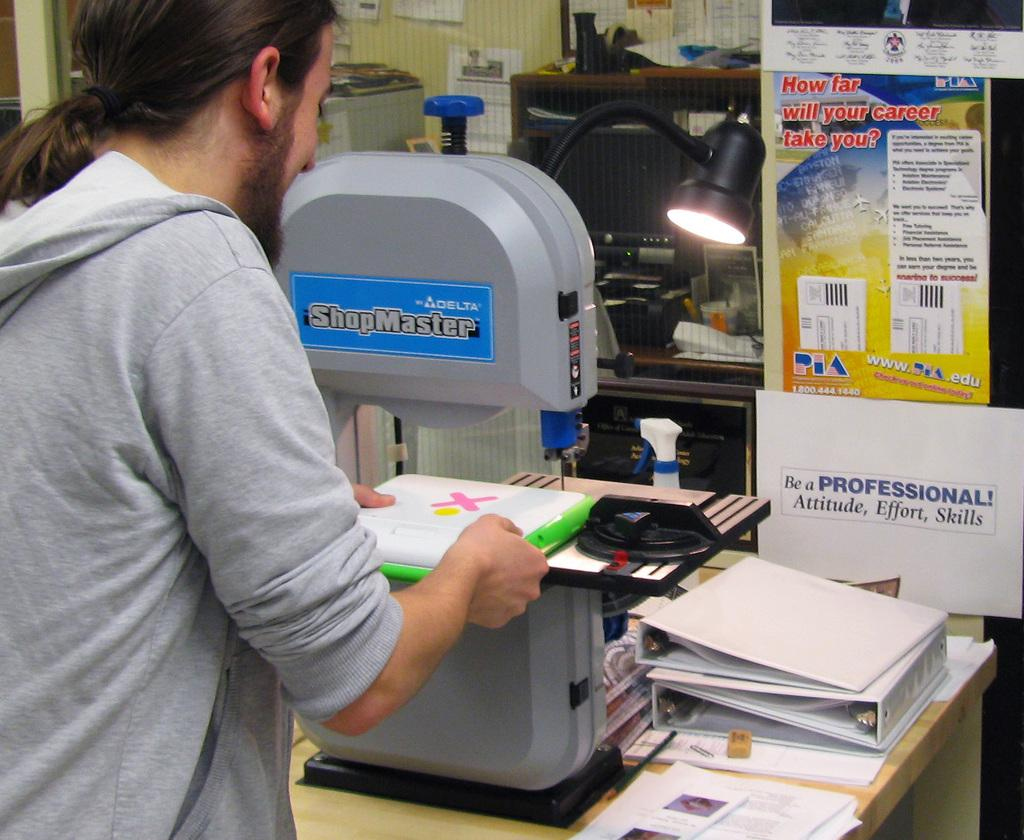Provide a one-sentence caption for the provided image. A man wearing a gray sweatshirt is putting papers with an X on a table. 